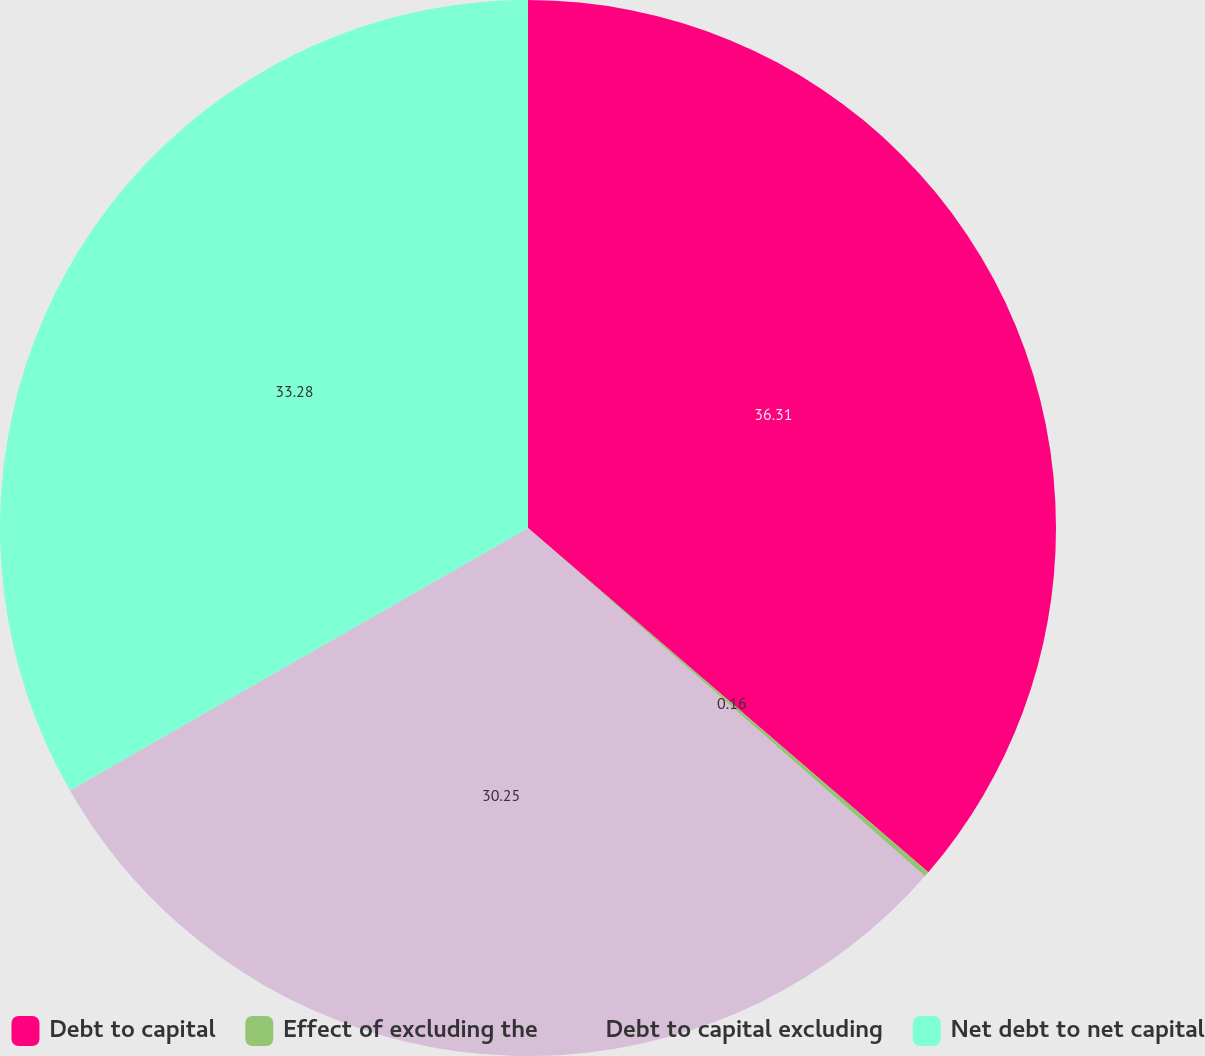Convert chart. <chart><loc_0><loc_0><loc_500><loc_500><pie_chart><fcel>Debt to capital<fcel>Effect of excluding the<fcel>Debt to capital excluding<fcel>Net debt to net capital<nl><fcel>36.3%<fcel>0.16%<fcel>30.25%<fcel>33.28%<nl></chart> 